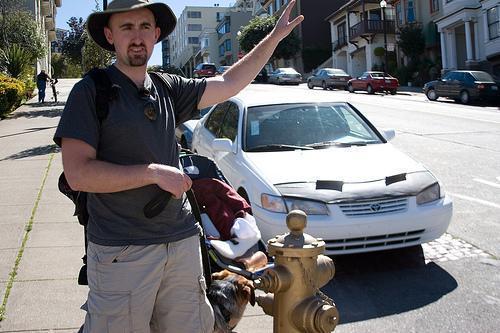How many people in the photo?
Give a very brief answer. 2. How many cars on the street?
Give a very brief answer. 7. How many vehicles are facing forward towards the camera?
Give a very brief answer. 1. 